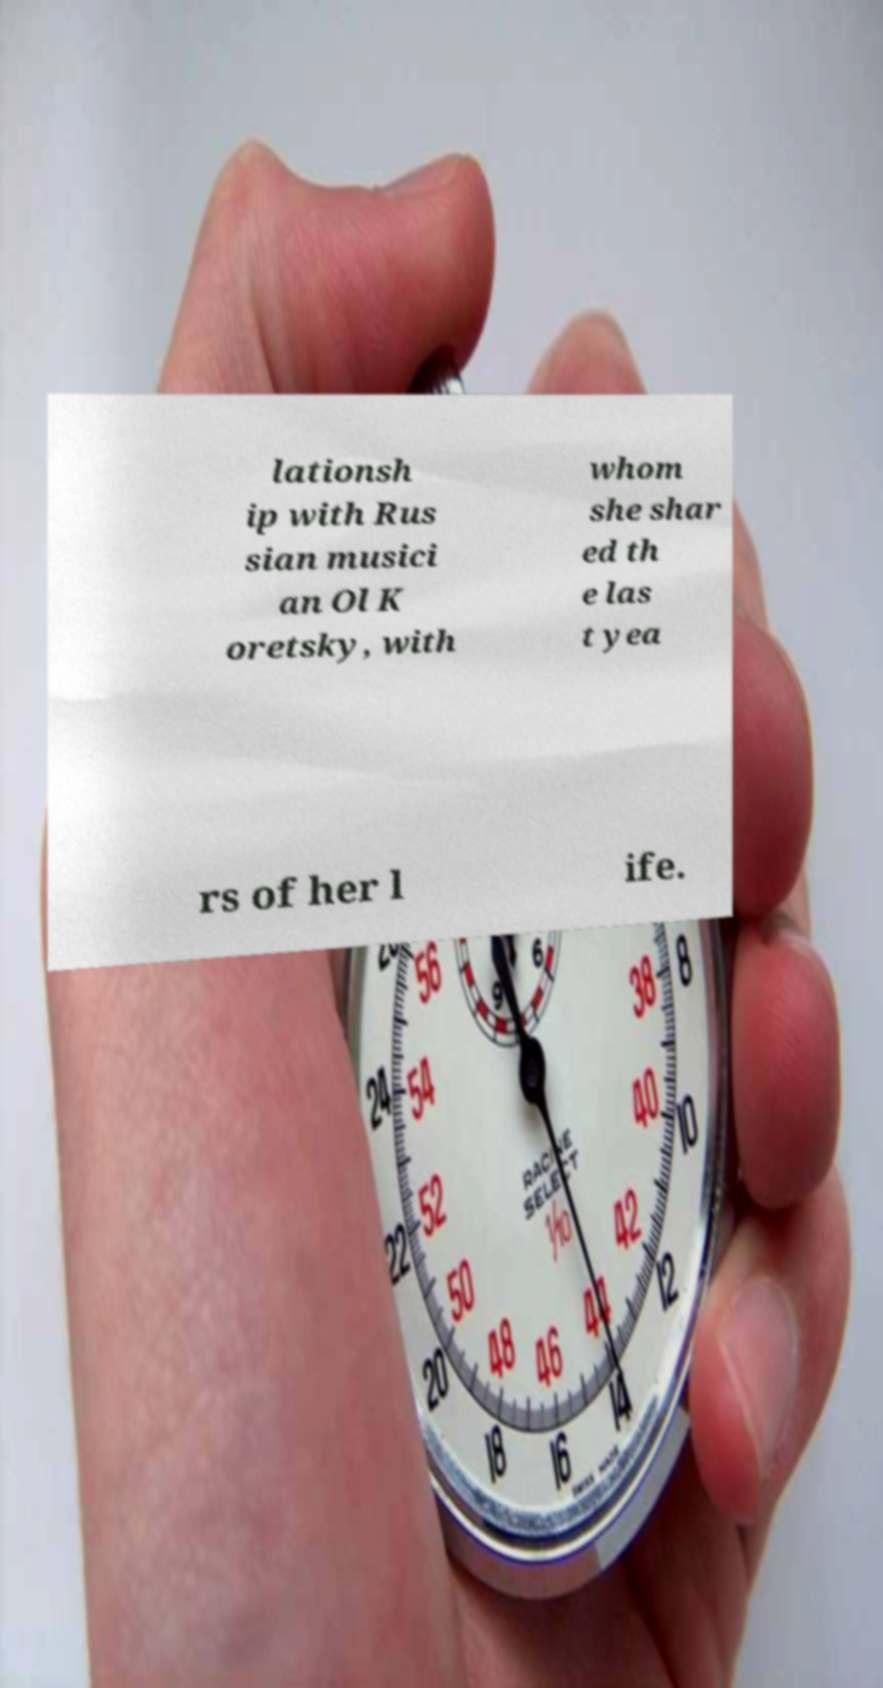Please read and relay the text visible in this image. What does it say? lationsh ip with Rus sian musici an Ol K oretsky, with whom she shar ed th e las t yea rs of her l ife. 